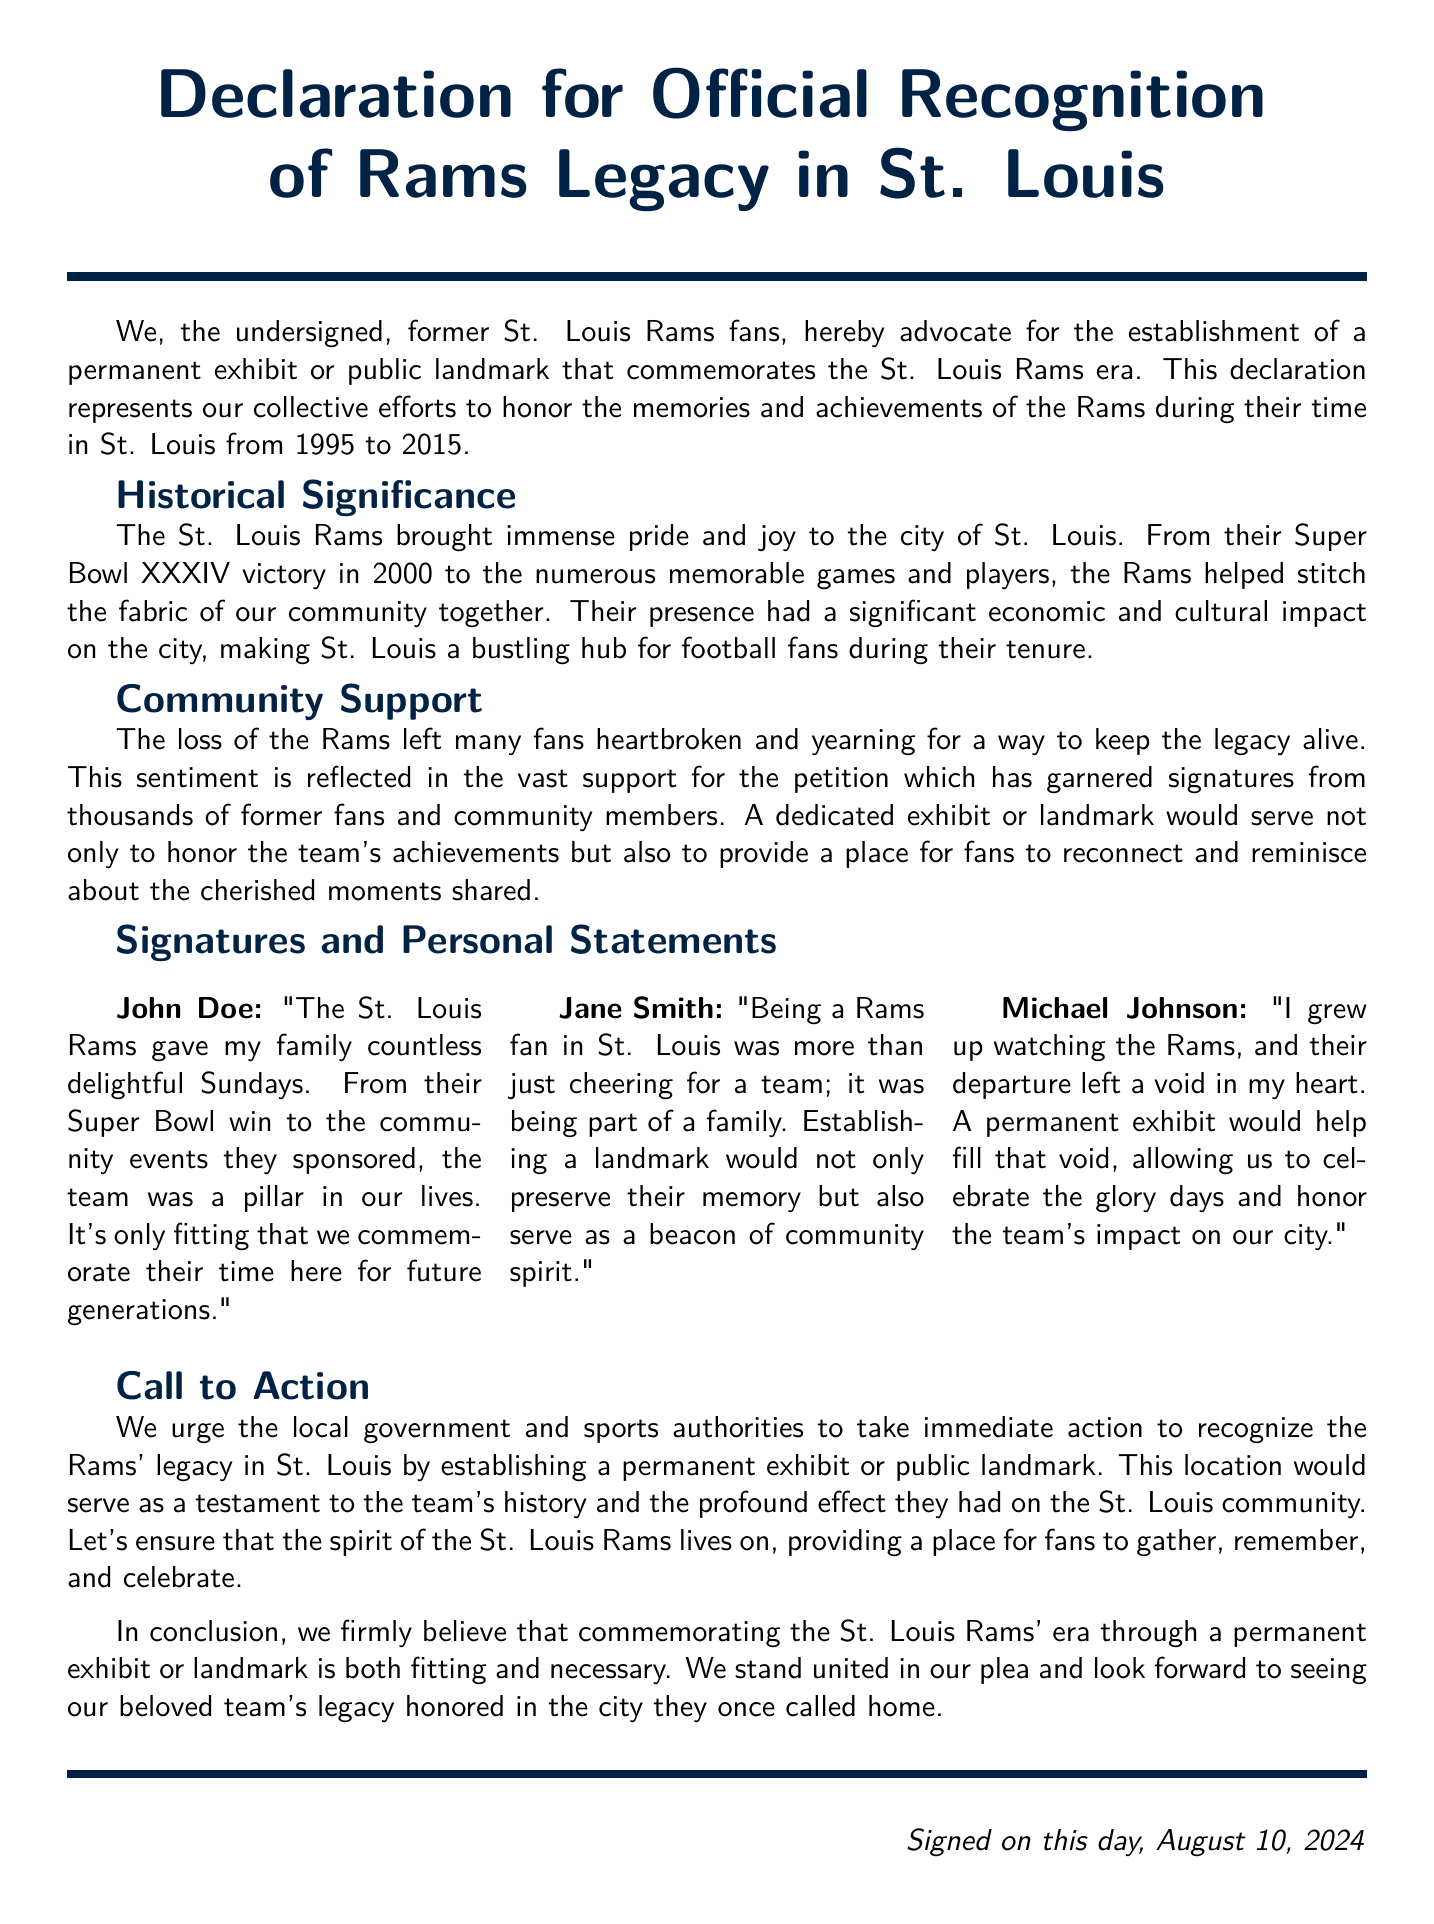What year did the Rams' era in St. Louis begin? The document states that the Rams were in St. Louis from 1995 to 2015, indicating the start year.
Answer: 1995 Who signed the declaration with the statement about family memories? The document includes a personal statement from John Doe about family Sundays and memorable events.
Answer: John Doe How many fans have signed the petition? The document mentions that the petition has garnered signatures from thousands of former fans and community members.
Answer: Thousands What was the outcome of Super Bowl XXXIV? The document notes that the Rams had a victory in Super Bowl XXXIV in 2000.
Answer: Victory What is the main call to action in the declaration? The document urges local government and sports authorities to take immediate action to recognize the Rams' legacy through a permanent exhibit or landmark.
Answer: Establish a permanent exhibit or public landmark What year did the Rams leave St. Louis? The document specifies the Rams' final year in St. Louis was 2015.
Answer: 2015 What color is associated with the Rams in the document? The document defines a color called ramsblue, which is frequently used in the text and headings.
Answer: Rams blue Who expressed the sentiment of missing the Rams deeply? Michael Johnson's statement indicates his deep feelings regarding the Rams' departure.
Answer: Michael Johnson 